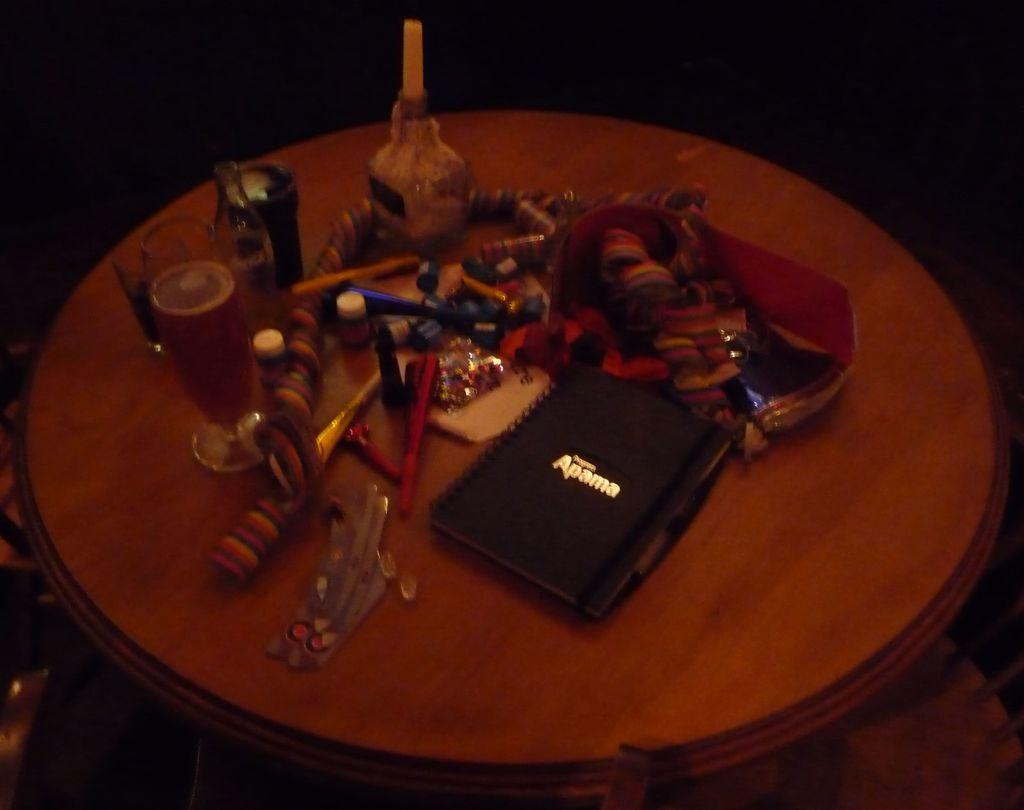<image>
Create a compact narrative representing the image presented. A round table has many different items on it including a glass of beer and a notebook that says Apama on the front. 